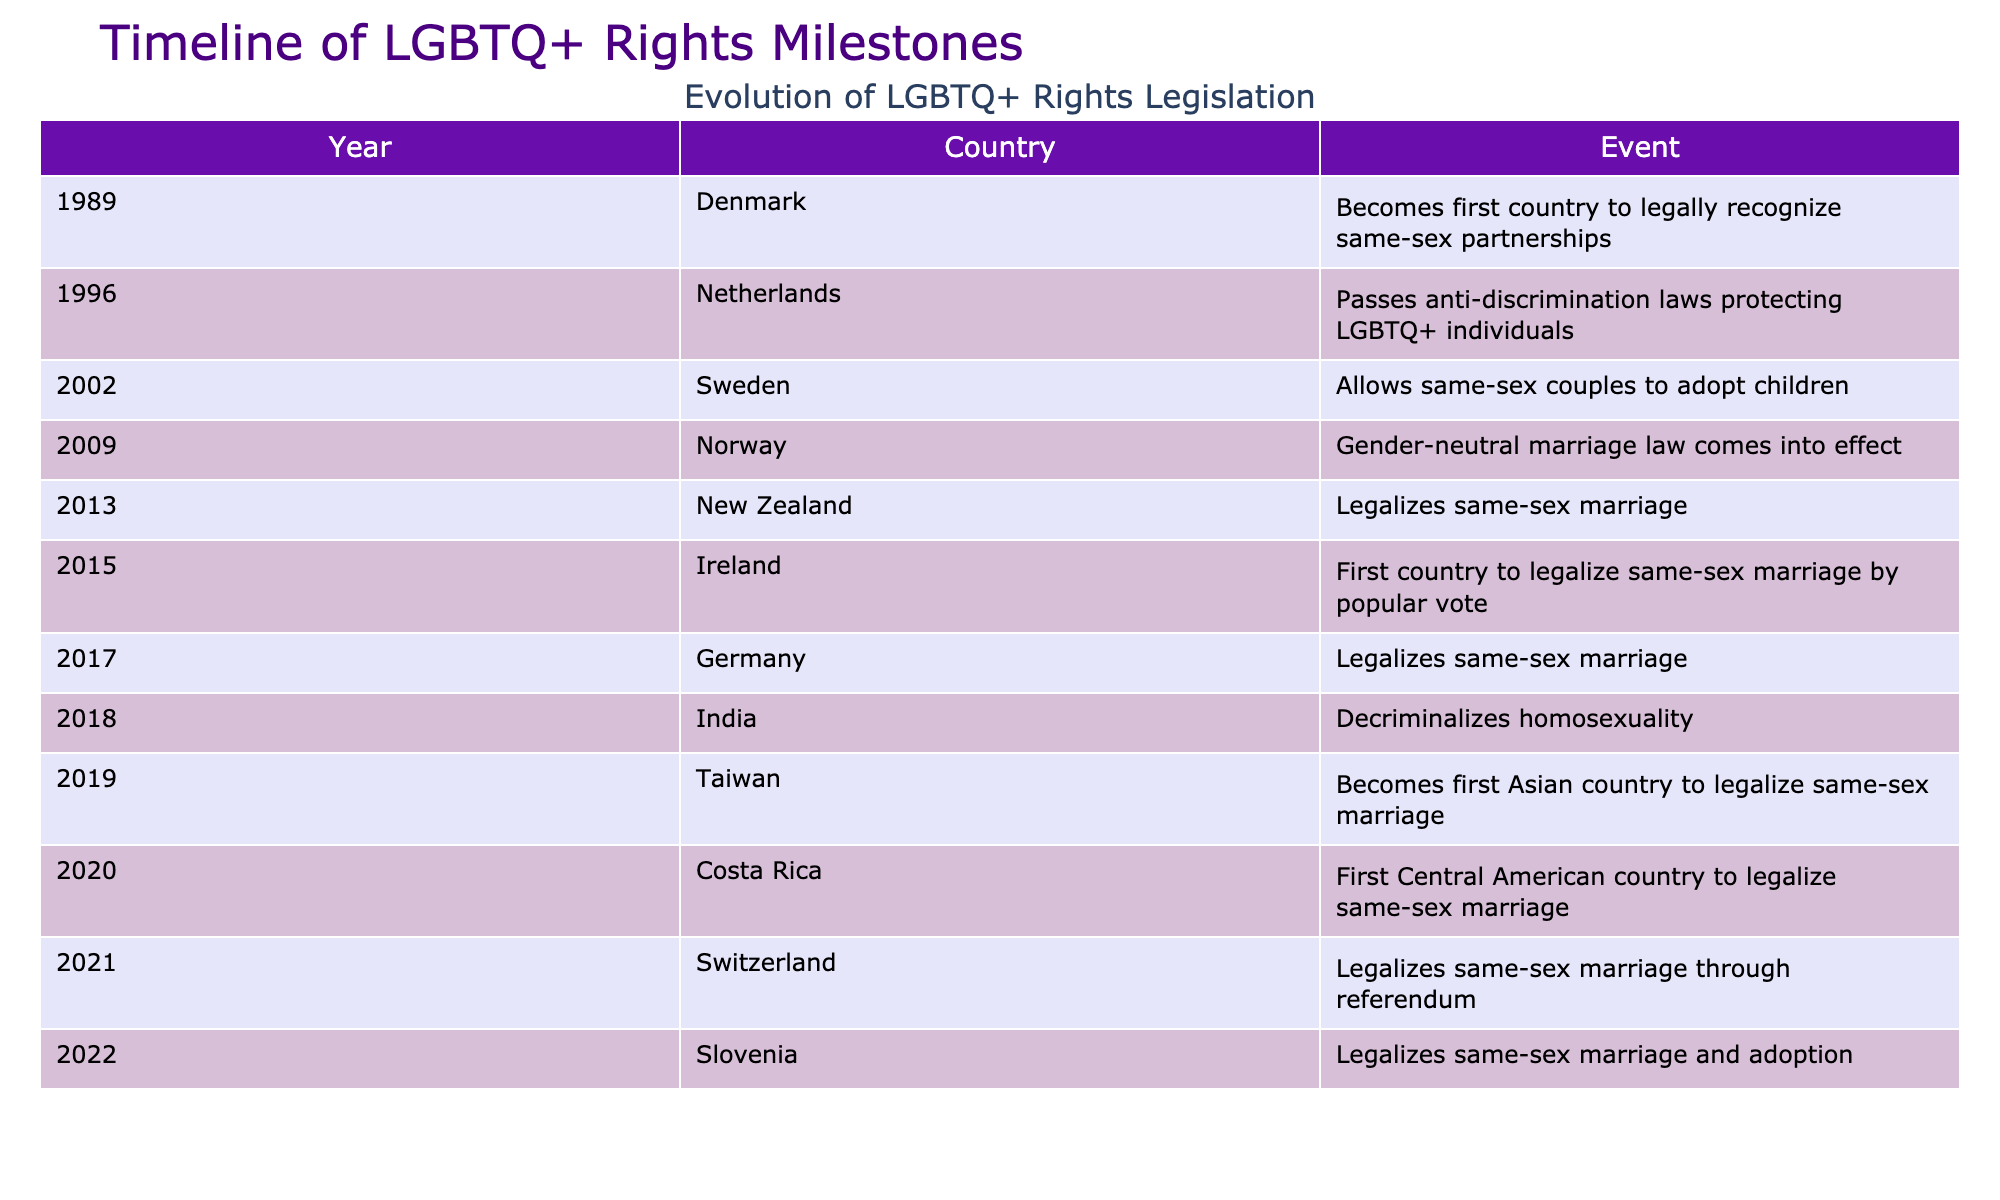What year did Denmark recognize same-sex partnerships? The table shows that Denmark was the first country to legally recognize same-sex partnerships in the year 1989.
Answer: 1989 How many countries legalized same-sex marriage between 2013 and 2019? According to the table, the countries that legalized same-sex marriage during this period are New Zealand (2013), Germany (2017), and Taiwan (2019). Count: 3.
Answer: 3 Did Costa Rica legalize same-sex marriage before India? The table shows that Costa Rica legalized same-sex marriage in 2020, while India decriminalized homosexuality in 2018 but did not legalize same-sex marriage until later. Thus, yes, Costa Rica did it after India.
Answer: Yes Which country was the first to legalize same-sex marriage in Asia? Referring to the table, Taiwan is indicated as the first Asian country to legalize same-sex marriage in 2019.
Answer: Taiwan How many years passed between the legalization of same-sex marriage in New Zealand and the first Central American country to do so? Examining the table, New Zealand legalized same-sex marriage in 2013 and Costa Rica did so in 2020. The time between these years is 2020 - 2013 = 7 years.
Answer: 7 years What is the total number of events listed for LGBTQ+ rights legislation? The table contains a total of 12 distinct events related to LGBTQ+ rights legislation across different countries, as noted in each row.
Answer: 12 Which country legalized same-sex marriage through a referendum? The table indicates that Switzerland was the country that legalized same-sex marriage through a referendum in 2021.
Answer: Switzerland Was Germany's legalization of same-sex marriage the last in the table? The last event listed in the table is Slovenia, which legalized same-sex marriage and adoption in 2022. Thus, Germany's legalization in 2017 is not the last.
Answer: No 